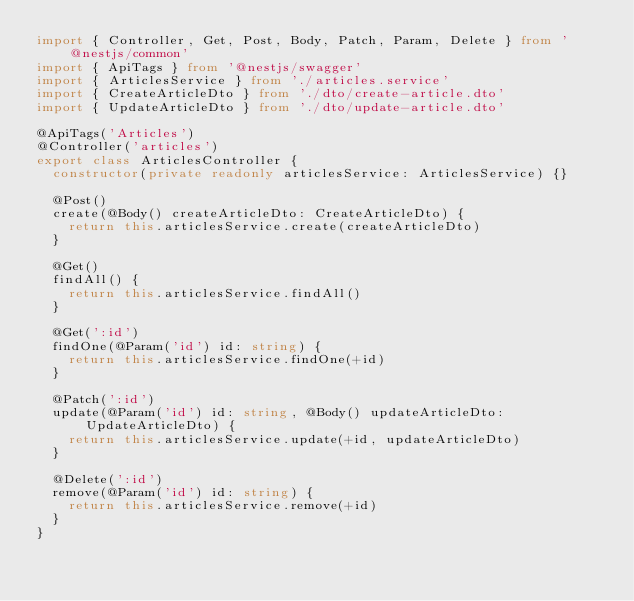<code> <loc_0><loc_0><loc_500><loc_500><_TypeScript_>import { Controller, Get, Post, Body, Patch, Param, Delete } from '@nestjs/common'
import { ApiTags } from '@nestjs/swagger'
import { ArticlesService } from './articles.service'
import { CreateArticleDto } from './dto/create-article.dto'
import { UpdateArticleDto } from './dto/update-article.dto'

@ApiTags('Articles')
@Controller('articles')
export class ArticlesController {
  constructor(private readonly articlesService: ArticlesService) {}

  @Post()
  create(@Body() createArticleDto: CreateArticleDto) {
    return this.articlesService.create(createArticleDto)
  }

  @Get()
  findAll() {
    return this.articlesService.findAll()
  }

  @Get(':id')
  findOne(@Param('id') id: string) {
    return this.articlesService.findOne(+id)
  }

  @Patch(':id')
  update(@Param('id') id: string, @Body() updateArticleDto: UpdateArticleDto) {
    return this.articlesService.update(+id, updateArticleDto)
  }

  @Delete(':id')
  remove(@Param('id') id: string) {
    return this.articlesService.remove(+id)
  }
}
</code> 